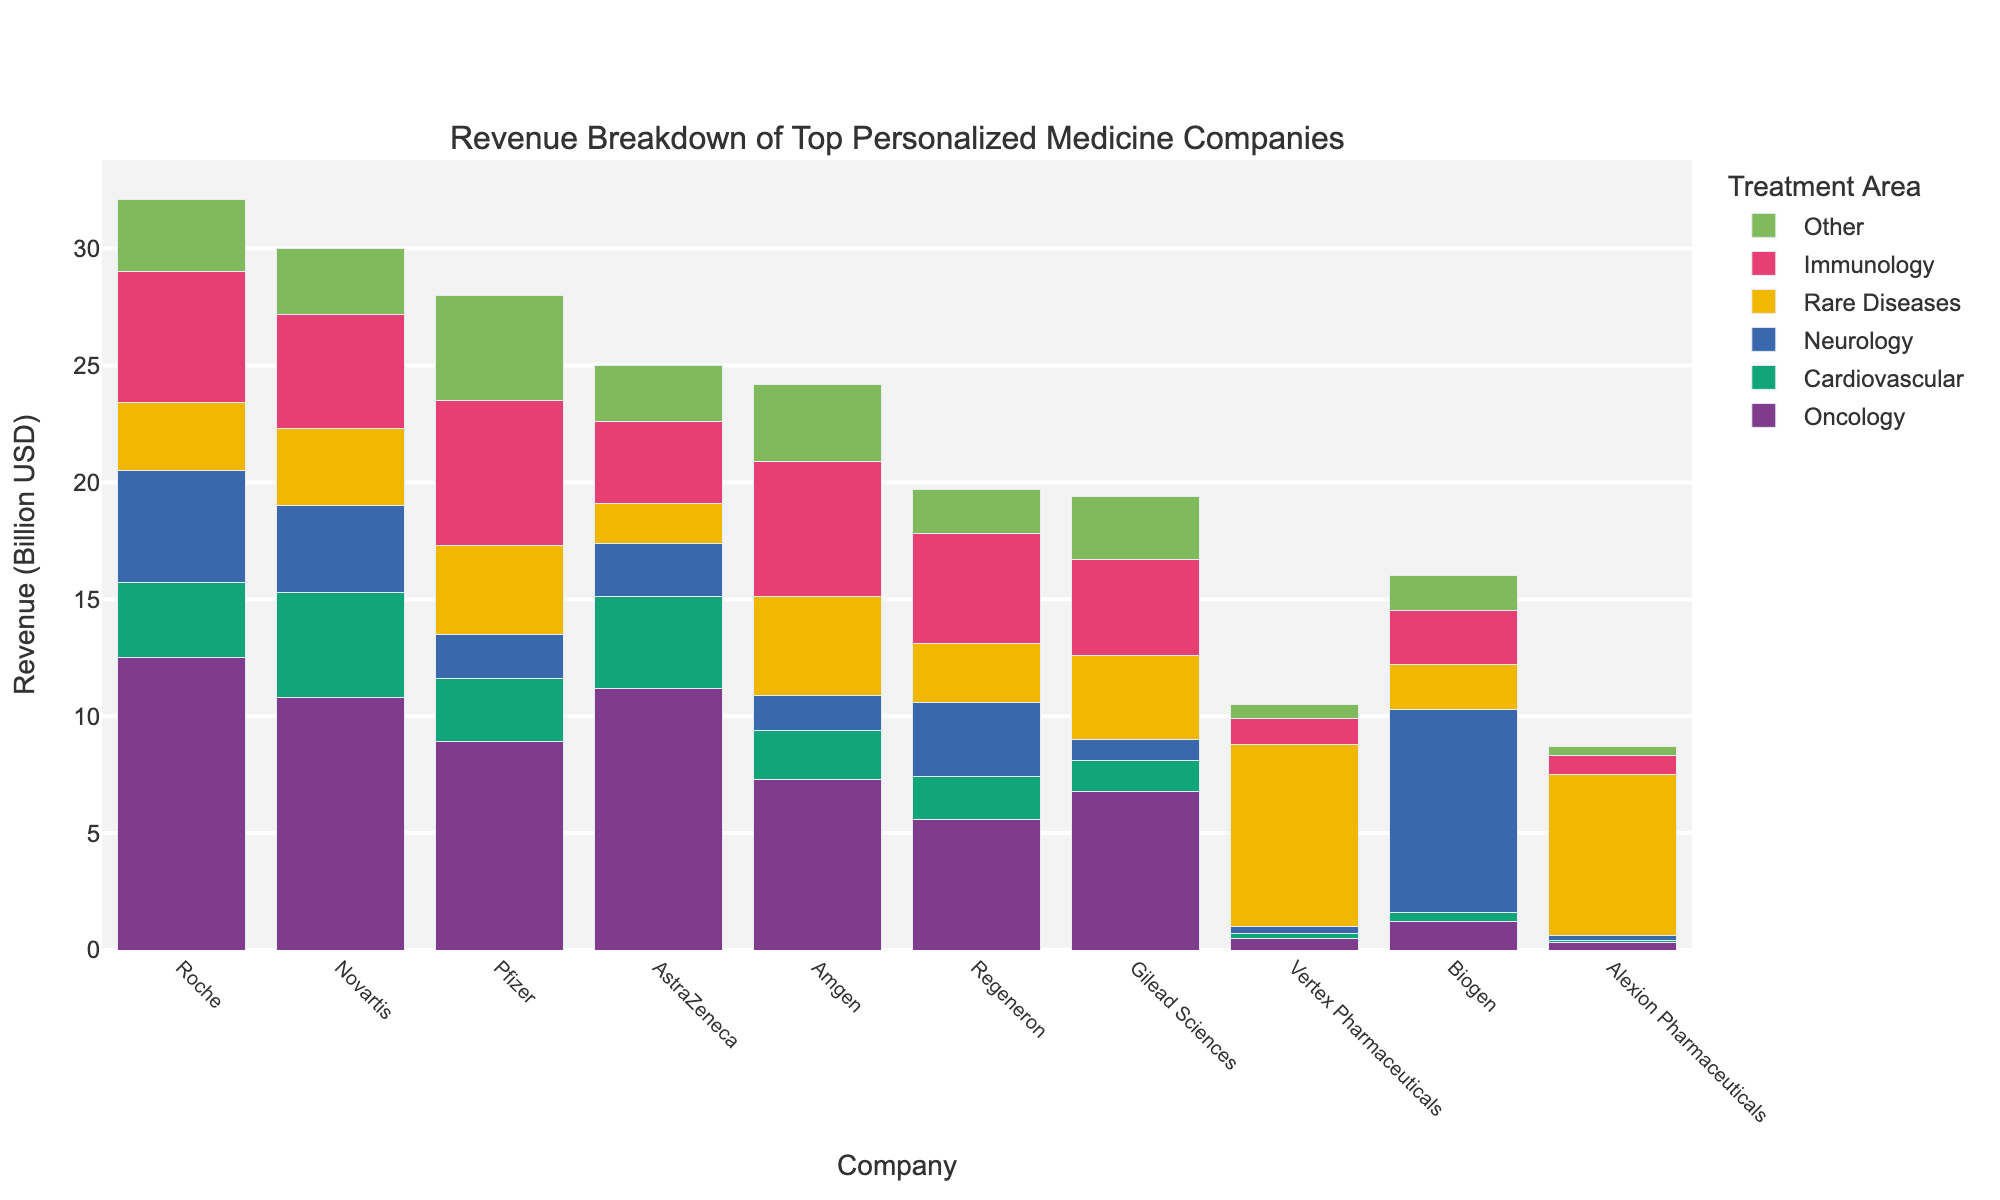Which company has the highest revenue in Oncology? By visually comparing the heights of the bars under the "Oncology" section, Roche has the tallest bar, indicating the highest revenue.
Answer: Roche What is the total revenue of Pfizer across all treatment areas? Sum the heights of Pfizer's bars across all the treatment areas: 8.9 (Oncology) + 2.7 (Cardiovascular) + 1.9 (Neurology) + 3.8 (Rare Diseases) + 6.2 (Immunology) + 4.5 (Other) = 28.0
Answer: 28.0 billion USD Which company generates more revenue from Neurology, Biogen or Novartis? By comparing the heights of the Neurology bars for Biogen and Novartis, Biogen's bar is taller than Novartis's.
Answer: Biogen What is the combined revenue of AstraZeneca in Cardiovascular and Immunology treatment areas? Sum the heights of AstraZeneca's Cardiovascular and Immunology bars: 3.9 (Cardiovascular) + 3.5 (Immunology) = 7.4
Answer: 7.4 billion USD Which treatment area contributes the least to Vertex Pharmaceuticals' revenue? By comparing the heights of the bars under Vertex Pharmaceuticals, the shortest bar is for Cardiovascular.
Answer: Cardiovascular How much more revenue does Roche generate in Oncology compared to Regeneron? Subtract Regeneron's Oncology revenue from Roche's Oncology revenue: 12.5 (Roche) - 5.6 (Regeneron) = 6.9
Answer: 6.9 billion USD Among the companies, who has the highest revenue in Rare Diseases? By visually comparing the heights of the bars under the "Rare Diseases" section, Vertex Pharmaceuticals has the tallest bar.
Answer: Vertex Pharmaceuticals What is the average revenue of Gilead Sciences in Cardiovascular, Neurology, and Rare Diseases? Sum the revenues in Cardiovascular, Neurology, and Rare Diseases and then divide by 3: (1.3 + 0.9 + 3.6) / 3 = 1.93
Answer: 1.93 billion USD Which company has the lowest total revenue across all treatment areas? Sum the revenues for each company and visually compare the totals; Alexion Pharmaceuticals has the lowest total.
Answer: Alexion Pharmaceuticals How much total revenue does Amgen generate in treatments outside Oncology? Sum the revenues in non-Oncology areas: 2.1 (Cardiovascular) + 1.5 (Neurology) + 4.2 (Rare Diseases) + 5.8 (Immunology) + 3.3 (Other) = 16.9
Answer: 16.9 billion USD 